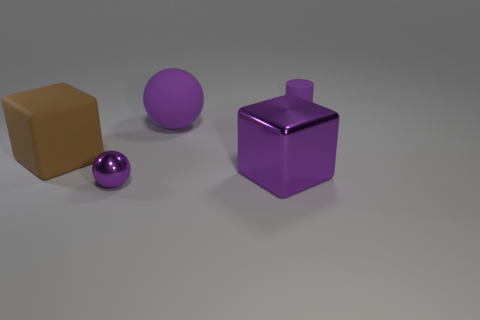There is a metallic object that is on the left side of the purple metallic thing right of the large purple ball that is behind the big purple cube; what is its color?
Make the answer very short. Purple. What color is the tiny cylinder that is the same material as the large ball?
Provide a short and direct response. Purple. What number of small purple objects are made of the same material as the big brown block?
Your answer should be compact. 1. Do the cube that is left of the purple metallic ball and the matte ball have the same size?
Make the answer very short. Yes. There is a shiny cube that is the same size as the matte cube; what is its color?
Ensure brevity in your answer.  Purple. There is a purple metallic block; what number of brown cubes are behind it?
Your response must be concise. 1. Are there any big shiny objects?
Give a very brief answer. Yes. There is a purple thing that is to the left of the purple matte object in front of the object that is right of the purple block; what size is it?
Ensure brevity in your answer.  Small. What number of other objects are there of the same size as the shiny ball?
Your answer should be compact. 1. There is a matte object that is to the left of the small metallic ball; what size is it?
Make the answer very short. Large. 